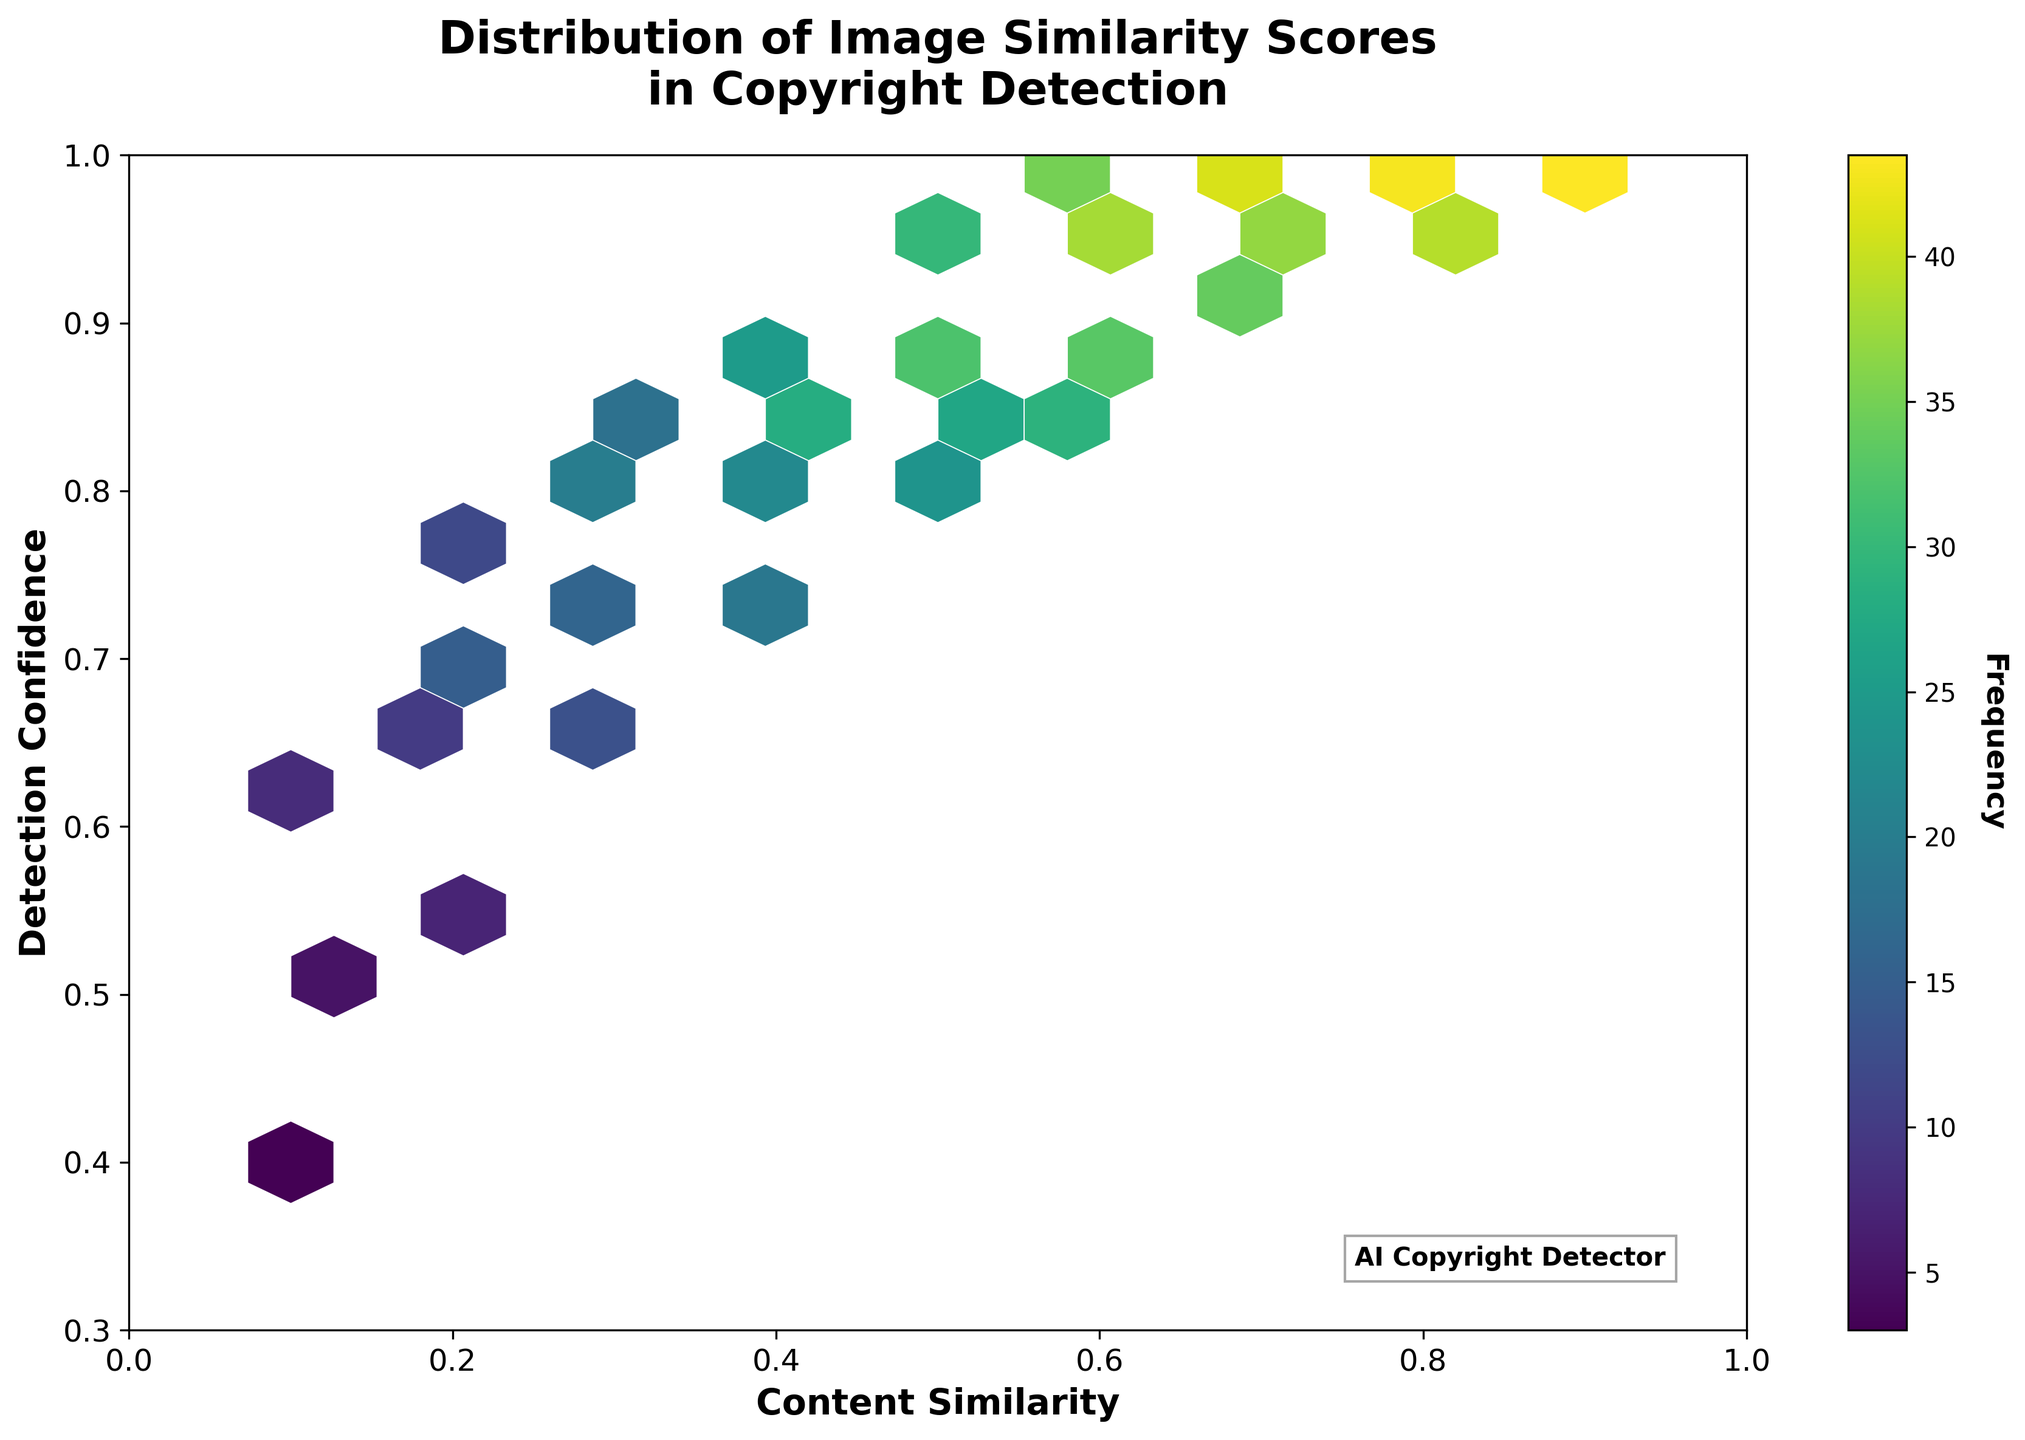What's the title of the figure? The title is usually located at the top of the figure. In this case, it's written as 'Distribution of Image Similarity Scores in Copyright Detection'.
Answer: Distribution of Image Similarity Scores in Copyright Detection What do the x-axis and y-axis represent? The labels on the x-axis and y-axis describe what each axis represents. The x-axis is labeled 'Content Similarity' while the y-axis is labeled 'Detection Confidence'.
Answer: Content Similarity and Detection Confidence What does the color intensity in the hexagonal bins represent? The color intensity in hexagonal bins indicates the frequency of data points in each bin. The color bar on the right side of the figure shows the relation between color intensity and frequency.
Answer: Frequency What is the range of Detection Confidence shown in the plot? By looking at the y-axis limits, we can see that the range of Detection Confidence is from 0.3 to 1.0.
Answer: 0.3 to 1.0 Which hexagonal bin has the highest count? The bins with the highest count have the most intense color. The color bar can be used to discern the exact frequency. The bin around the point (0.7, 0.99) appears to have the highest intensity, corresponding to the highest frequency value, as indicated by the data point count of 45.
Answer: Around (0.7, 0.99) How many bins have a frequency greater than 30? Look for bins with color intensity that corresponds to frequencies higher than 30. From the color bar and their positions, we see bins around (0.6, 0.98), (0.7, 0.99), and (0.8, 0.99) have counts of 35, 40, and 45 respectively. Further, bins around (0.5, 0.9), (0.6. 0.95), and (0.7, 0.98) have counts of 32, 38 and 42 respectively — leading to a total of 7 bins.
Answer: 7 Which range of Content Similarity has the least observed data points? Observing the color intensity and sparsity, areas around the content similarity value of 0.1 appear to have the least intense and sparse bins, indicating fewer data points.
Answer: Around 0.1 Do higher Content Similarity values tend to have higher Detection Confidence? By comparing the distribution, we see that higher Content Similarity values (closer to 1.0) are mostly clustered in higher Detection Confidence areas (also closer to 1).
Answer: Yes What is the general trend observed between Content Similarity and Detection Confidence? The general trend from the figure shows that as Content Similarity increases, the Detection Confidence also tends to increase, as indicated by the clustering of higher values in both dimensions.
Answer: As Content Similarity increases, Detection Confidence also increases 